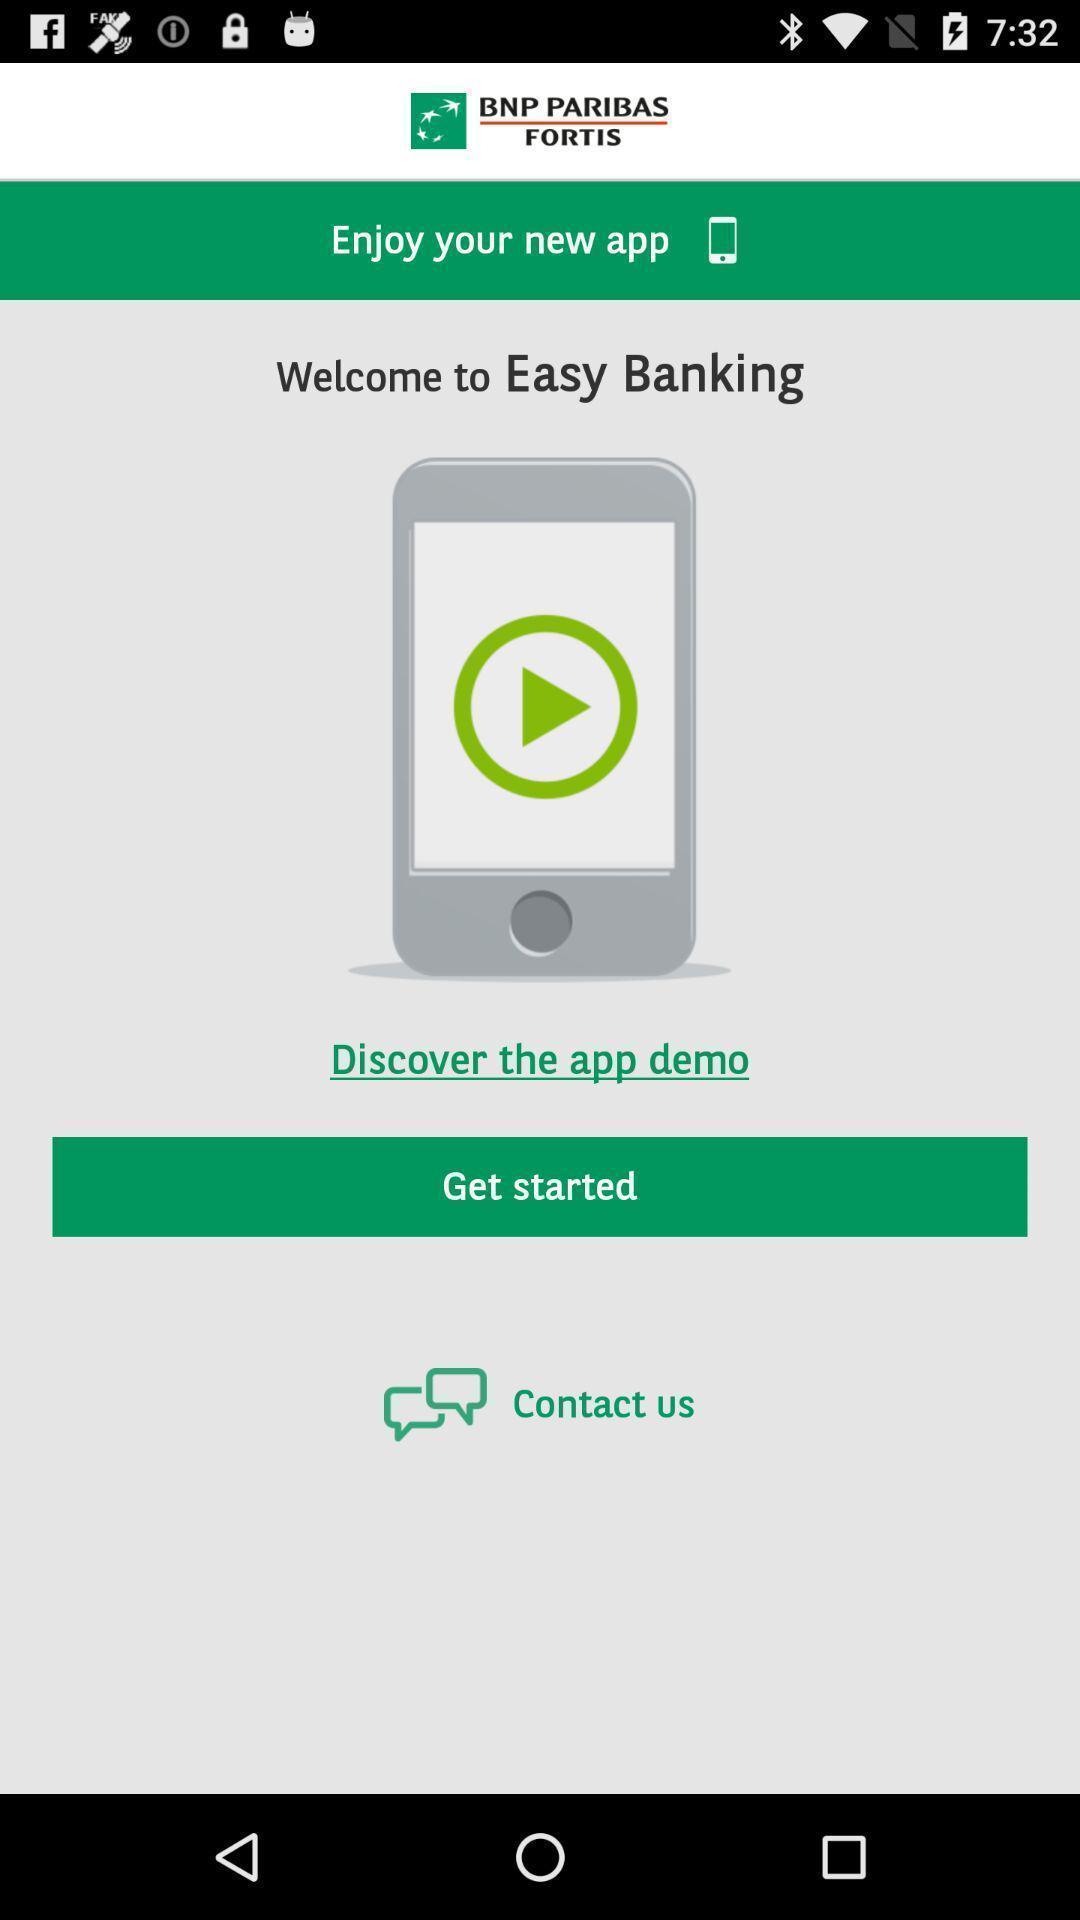Describe the content in this image. Welcome page of an banking application with get started option. 